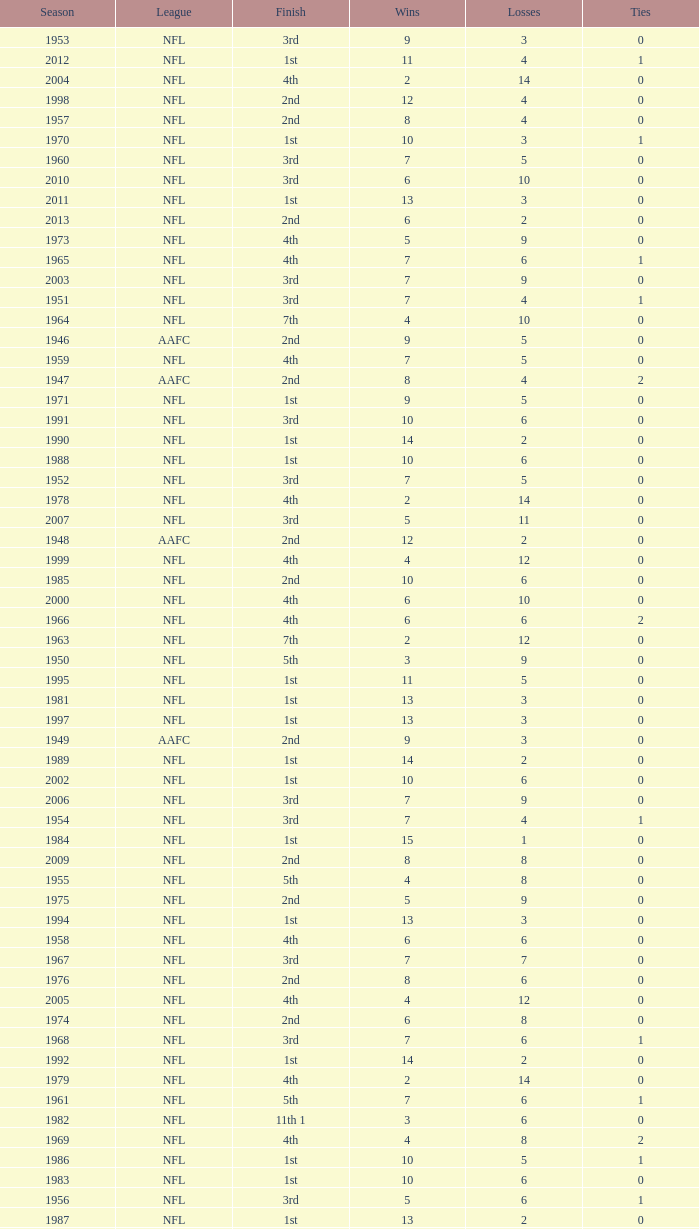Could you help me parse every detail presented in this table? {'header': ['Season', 'League', 'Finish', 'Wins', 'Losses', 'Ties'], 'rows': [['1953', 'NFL', '3rd', '9', '3', '0'], ['2012', 'NFL', '1st', '11', '4', '1'], ['2004', 'NFL', '4th', '2', '14', '0'], ['1998', 'NFL', '2nd', '12', '4', '0'], ['1957', 'NFL', '2nd', '8', '4', '0'], ['1970', 'NFL', '1st', '10', '3', '1'], ['1960', 'NFL', '3rd', '7', '5', '0'], ['2010', 'NFL', '3rd', '6', '10', '0'], ['2011', 'NFL', '1st', '13', '3', '0'], ['2013', 'NFL', '2nd', '6', '2', '0'], ['1973', 'NFL', '4th', '5', '9', '0'], ['1965', 'NFL', '4th', '7', '6', '1'], ['2003', 'NFL', '3rd', '7', '9', '0'], ['1951', 'NFL', '3rd', '7', '4', '1'], ['1964', 'NFL', '7th', '4', '10', '0'], ['1946', 'AAFC', '2nd', '9', '5', '0'], ['1959', 'NFL', '4th', '7', '5', '0'], ['1947', 'AAFC', '2nd', '8', '4', '2'], ['1971', 'NFL', '1st', '9', '5', '0'], ['1991', 'NFL', '3rd', '10', '6', '0'], ['1990', 'NFL', '1st', '14', '2', '0'], ['1988', 'NFL', '1st', '10', '6', '0'], ['1952', 'NFL', '3rd', '7', '5', '0'], ['1978', 'NFL', '4th', '2', '14', '0'], ['2007', 'NFL', '3rd', '5', '11', '0'], ['1948', 'AAFC', '2nd', '12', '2', '0'], ['1999', 'NFL', '4th', '4', '12', '0'], ['1985', 'NFL', '2nd', '10', '6', '0'], ['2000', 'NFL', '4th', '6', '10', '0'], ['1966', 'NFL', '4th', '6', '6', '2'], ['1963', 'NFL', '7th', '2', '12', '0'], ['1950', 'NFL', '5th', '3', '9', '0'], ['1995', 'NFL', '1st', '11', '5', '0'], ['1981', 'NFL', '1st', '13', '3', '0'], ['1997', 'NFL', '1st', '13', '3', '0'], ['1949', 'AAFC', '2nd', '9', '3', '0'], ['1989', 'NFL', '1st', '14', '2', '0'], ['2002', 'NFL', '1st', '10', '6', '0'], ['2006', 'NFL', '3rd', '7', '9', '0'], ['1954', 'NFL', '3rd', '7', '4', '1'], ['1984', 'NFL', '1st', '15', '1', '0'], ['2009', 'NFL', '2nd', '8', '8', '0'], ['1955', 'NFL', '5th', '4', '8', '0'], ['1975', 'NFL', '2nd', '5', '9', '0'], ['1994', 'NFL', '1st', '13', '3', '0'], ['1958', 'NFL', '4th', '6', '6', '0'], ['1967', 'NFL', '3rd', '7', '7', '0'], ['1976', 'NFL', '2nd', '8', '6', '0'], ['2005', 'NFL', '4th', '4', '12', '0'], ['1974', 'NFL', '2nd', '6', '8', '0'], ['1968', 'NFL', '3rd', '7', '6', '1'], ['1992', 'NFL', '1st', '14', '2', '0'], ['1979', 'NFL', '4th', '2', '14', '0'], ['1961', 'NFL', '5th', '7', '6', '1'], ['1982', 'NFL', '11th 1', '3', '6', '0'], ['1969', 'NFL', '4th', '4', '8', '2'], ['1986', 'NFL', '1st', '10', '5', '1'], ['1983', 'NFL', '1st', '10', '6', '0'], ['1956', 'NFL', '3rd', '5', '6', '1'], ['1987', 'NFL', '1st', '13', '2', '0'], ['1977', 'NFL', '3rd', '5', '9', '0'], ['1993', 'NFL', '1st', '10', '6', '0'], ['2001', 'NFL', '2nd', '12', '4', '0'], ['1962', 'NFL', '5th', '6', '8', '0'], ['1980', 'NFL', '3rd', '6', '10', '0'], ['1996', 'NFL', '2nd', '12', '4', '0'], ['2008', 'NFL', '2nd', '7', '9', '0'], ['1972', 'NFL', '1st', '8', '5', '1']]} What is the losses in the NFL in the 2011 season with less than 13 wins? None. 